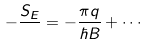<formula> <loc_0><loc_0><loc_500><loc_500>- \frac { S _ { E } } { } = - \frac { \pi q } { \hbar { B } } + \cdots</formula> 